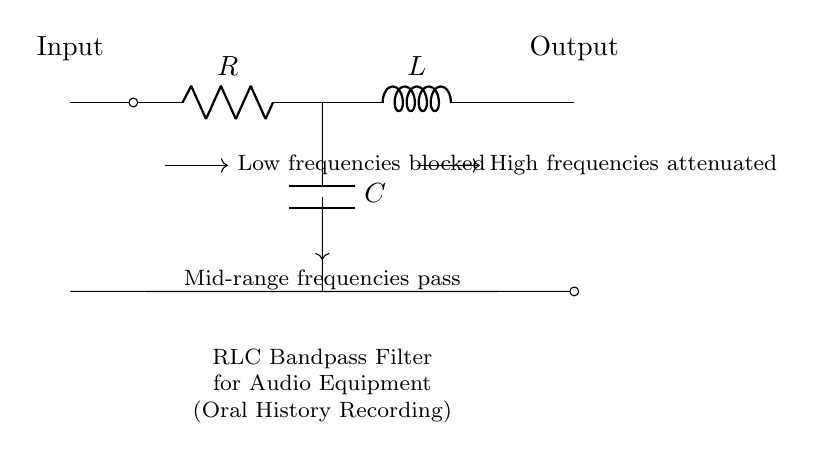What components are present in this circuit? The circuit contains a resistor, an inductor, and a capacitor, as indicated by their respective labels R, L, and C in the diagram.
Answer: Resistor, Inductor, Capacitor What is the function of this RLC circuit? This RLC circuit functions as a bandpass filter, which allows mid-range frequencies to pass while blocking low and high frequencies, as noted in the annotations around the components.
Answer: Bandpass filter Which component blocks low frequencies? The description notes that the resistor in conjunction with the inductor and capacitor allows specific frequencies to be filtered, with low frequencies being blocked.
Answer: Resistor What type of filter is represented in this circuit? The annotations clearly state that it is a bandpass filter, which is a type of circuit that allows a certain range of frequencies to pass while attenuating others.
Answer: Bandpass filter How are mid-range frequencies processed in the circuit? The circuit is designed to allow mid-range frequencies to pass through while low and high frequencies are blocked or attenuated, which is indicated by the directional arrows in the diagram that show how signals are filtered.
Answer: Mid-range frequencies pass What frequencies are attenuated in the output? The circuit design includes specific notes indicating that high frequencies are attenuated, meaning that they are reduced in intensity at the output, as shown by the corresponding arrow in the diagram.
Answer: High frequencies 